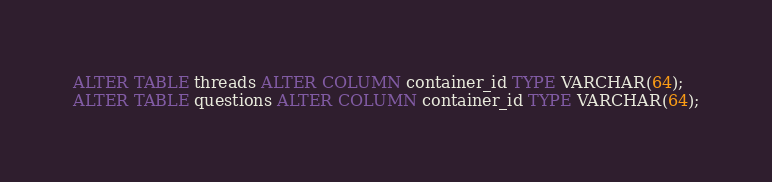Convert code to text. <code><loc_0><loc_0><loc_500><loc_500><_SQL_>ALTER TABLE threads ALTER COLUMN container_id TYPE VARCHAR(64);
ALTER TABLE questions ALTER COLUMN container_id TYPE VARCHAR(64);</code> 